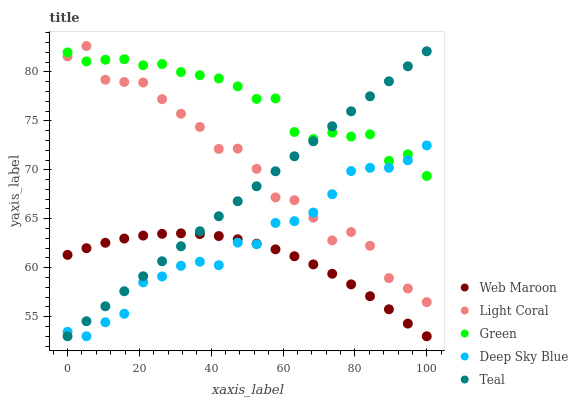Does Web Maroon have the minimum area under the curve?
Answer yes or no. Yes. Does Green have the maximum area under the curve?
Answer yes or no. Yes. Does Green have the minimum area under the curve?
Answer yes or no. No. Does Web Maroon have the maximum area under the curve?
Answer yes or no. No. Is Teal the smoothest?
Answer yes or no. Yes. Is Light Coral the roughest?
Answer yes or no. Yes. Is Green the smoothest?
Answer yes or no. No. Is Green the roughest?
Answer yes or no. No. Does Web Maroon have the lowest value?
Answer yes or no. Yes. Does Green have the lowest value?
Answer yes or no. No. Does Light Coral have the highest value?
Answer yes or no. Yes. Does Green have the highest value?
Answer yes or no. No. Is Web Maroon less than Green?
Answer yes or no. Yes. Is Light Coral greater than Web Maroon?
Answer yes or no. Yes. Does Light Coral intersect Deep Sky Blue?
Answer yes or no. Yes. Is Light Coral less than Deep Sky Blue?
Answer yes or no. No. Is Light Coral greater than Deep Sky Blue?
Answer yes or no. No. Does Web Maroon intersect Green?
Answer yes or no. No. 